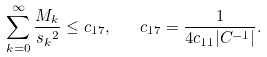<formula> <loc_0><loc_0><loc_500><loc_500>\sum _ { k = 0 } ^ { \infty } \frac { M _ { k } } { { s _ { k } } ^ { 2 } } \leq c _ { 1 7 } , \quad c _ { 1 7 } = \frac { 1 } { 4 c _ { 1 1 } | C ^ { - 1 } | } .</formula> 